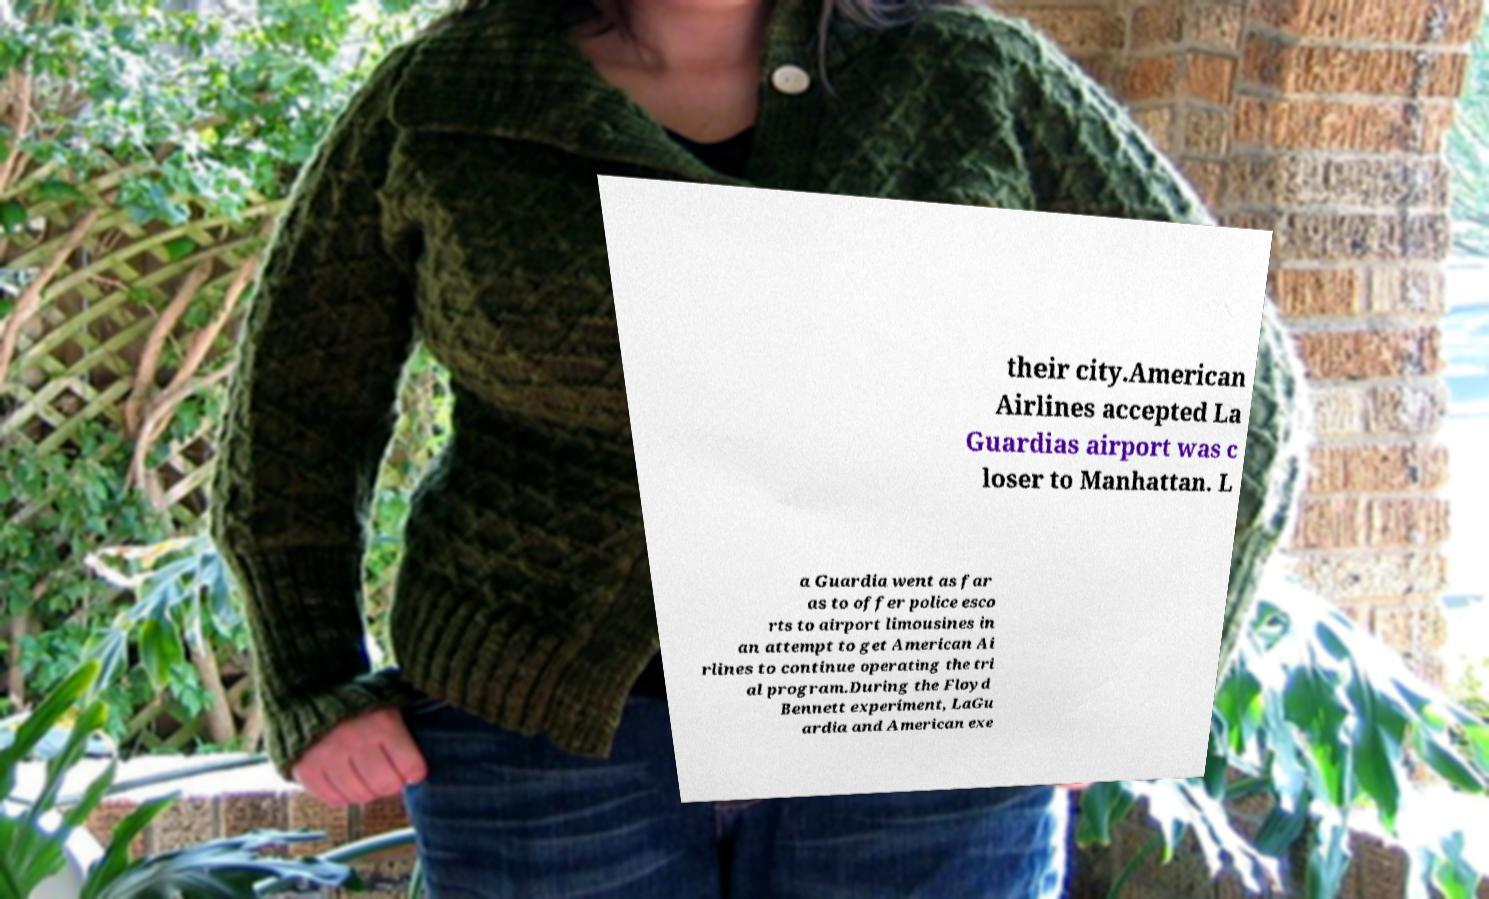I need the written content from this picture converted into text. Can you do that? their city.American Airlines accepted La Guardias airport was c loser to Manhattan. L a Guardia went as far as to offer police esco rts to airport limousines in an attempt to get American Ai rlines to continue operating the tri al program.During the Floyd Bennett experiment, LaGu ardia and American exe 